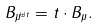<formula> <loc_0><loc_0><loc_500><loc_500>B _ { \mu ^ { \uplus t } } = t \cdot B _ { \mu } .</formula> 